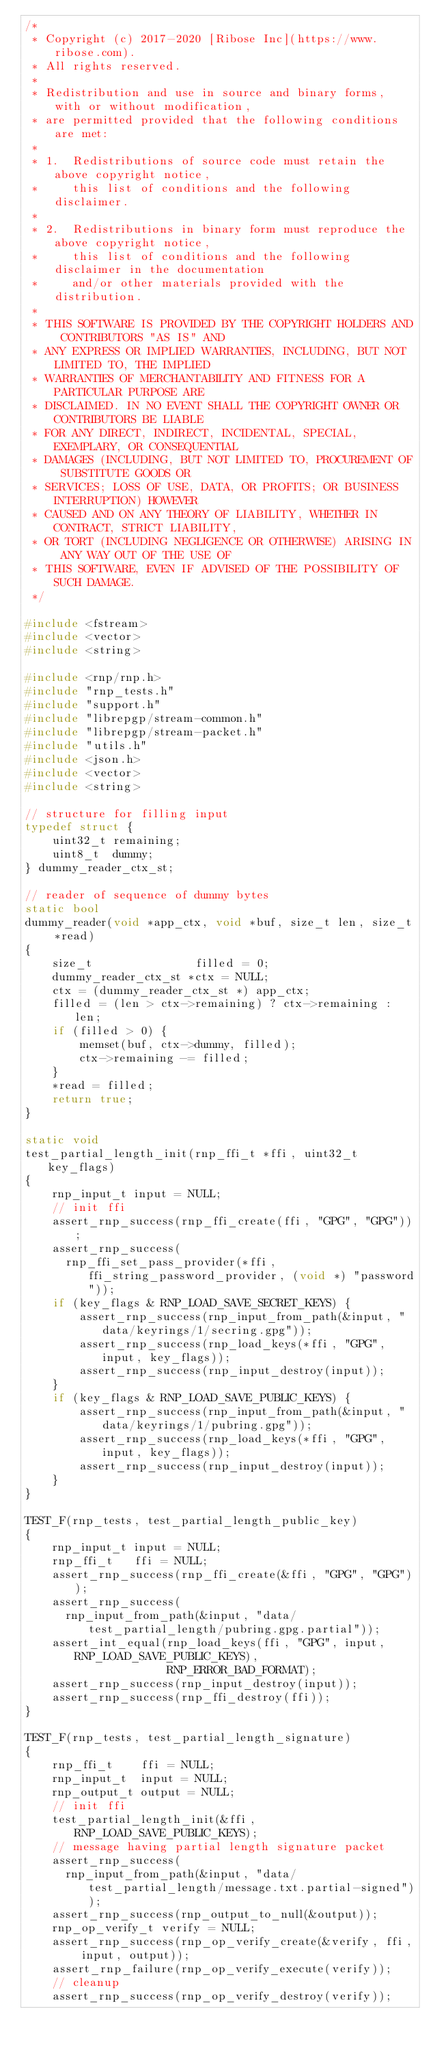<code> <loc_0><loc_0><loc_500><loc_500><_C++_>/*
 * Copyright (c) 2017-2020 [Ribose Inc](https://www.ribose.com).
 * All rights reserved.
 *
 * Redistribution and use in source and binary forms, with or without modification,
 * are permitted provided that the following conditions are met:
 *
 * 1.  Redistributions of source code must retain the above copyright notice,
 *     this list of conditions and the following disclaimer.
 *
 * 2.  Redistributions in binary form must reproduce the above copyright notice,
 *     this list of conditions and the following disclaimer in the documentation
 *     and/or other materials provided with the distribution.
 *
 * THIS SOFTWARE IS PROVIDED BY THE COPYRIGHT HOLDERS AND CONTRIBUTORS "AS IS" AND
 * ANY EXPRESS OR IMPLIED WARRANTIES, INCLUDING, BUT NOT LIMITED TO, THE IMPLIED
 * WARRANTIES OF MERCHANTABILITY AND FITNESS FOR A PARTICULAR PURPOSE ARE
 * DISCLAIMED. IN NO EVENT SHALL THE COPYRIGHT OWNER OR CONTRIBUTORS BE LIABLE
 * FOR ANY DIRECT, INDIRECT, INCIDENTAL, SPECIAL, EXEMPLARY, OR CONSEQUENTIAL
 * DAMAGES (INCLUDING, BUT NOT LIMITED TO, PROCUREMENT OF SUBSTITUTE GOODS OR
 * SERVICES; LOSS OF USE, DATA, OR PROFITS; OR BUSINESS INTERRUPTION) HOWEVER
 * CAUSED AND ON ANY THEORY OF LIABILITY, WHETHER IN CONTRACT, STRICT LIABILITY,
 * OR TORT (INCLUDING NEGLIGENCE OR OTHERWISE) ARISING IN ANY WAY OUT OF THE USE OF
 * THIS SOFTWARE, EVEN IF ADVISED OF THE POSSIBILITY OF SUCH DAMAGE.
 */

#include <fstream>
#include <vector>
#include <string>

#include <rnp/rnp.h>
#include "rnp_tests.h"
#include "support.h"
#include "librepgp/stream-common.h"
#include "librepgp/stream-packet.h"
#include "utils.h"
#include <json.h>
#include <vector>
#include <string>

// structure for filling input
typedef struct {
    uint32_t remaining;
    uint8_t  dummy;
} dummy_reader_ctx_st;

// reader of sequence of dummy bytes
static bool
dummy_reader(void *app_ctx, void *buf, size_t len, size_t *read)
{
    size_t               filled = 0;
    dummy_reader_ctx_st *ctx = NULL;
    ctx = (dummy_reader_ctx_st *) app_ctx;
    filled = (len > ctx->remaining) ? ctx->remaining : len;
    if (filled > 0) {
        memset(buf, ctx->dummy, filled);
        ctx->remaining -= filled;
    }
    *read = filled;
    return true;
}

static void
test_partial_length_init(rnp_ffi_t *ffi, uint32_t key_flags)
{
    rnp_input_t input = NULL;
    // init ffi
    assert_rnp_success(rnp_ffi_create(ffi, "GPG", "GPG"));
    assert_rnp_success(
      rnp_ffi_set_pass_provider(*ffi, ffi_string_password_provider, (void *) "password"));
    if (key_flags & RNP_LOAD_SAVE_SECRET_KEYS) {
        assert_rnp_success(rnp_input_from_path(&input, "data/keyrings/1/secring.gpg"));
        assert_rnp_success(rnp_load_keys(*ffi, "GPG", input, key_flags));
        assert_rnp_success(rnp_input_destroy(input));
    }
    if (key_flags & RNP_LOAD_SAVE_PUBLIC_KEYS) {
        assert_rnp_success(rnp_input_from_path(&input, "data/keyrings/1/pubring.gpg"));
        assert_rnp_success(rnp_load_keys(*ffi, "GPG", input, key_flags));
        assert_rnp_success(rnp_input_destroy(input));
    }
}

TEST_F(rnp_tests, test_partial_length_public_key)
{
    rnp_input_t input = NULL;
    rnp_ffi_t   ffi = NULL;
    assert_rnp_success(rnp_ffi_create(&ffi, "GPG", "GPG"));
    assert_rnp_success(
      rnp_input_from_path(&input, "data/test_partial_length/pubring.gpg.partial"));
    assert_int_equal(rnp_load_keys(ffi, "GPG", input, RNP_LOAD_SAVE_PUBLIC_KEYS),
                     RNP_ERROR_BAD_FORMAT);
    assert_rnp_success(rnp_input_destroy(input));
    assert_rnp_success(rnp_ffi_destroy(ffi));
}

TEST_F(rnp_tests, test_partial_length_signature)
{
    rnp_ffi_t    ffi = NULL;
    rnp_input_t  input = NULL;
    rnp_output_t output = NULL;
    // init ffi
    test_partial_length_init(&ffi, RNP_LOAD_SAVE_PUBLIC_KEYS);
    // message having partial length signature packet
    assert_rnp_success(
      rnp_input_from_path(&input, "data/test_partial_length/message.txt.partial-signed"));
    assert_rnp_success(rnp_output_to_null(&output));
    rnp_op_verify_t verify = NULL;
    assert_rnp_success(rnp_op_verify_create(&verify, ffi, input, output));
    assert_rnp_failure(rnp_op_verify_execute(verify));
    // cleanup
    assert_rnp_success(rnp_op_verify_destroy(verify));</code> 